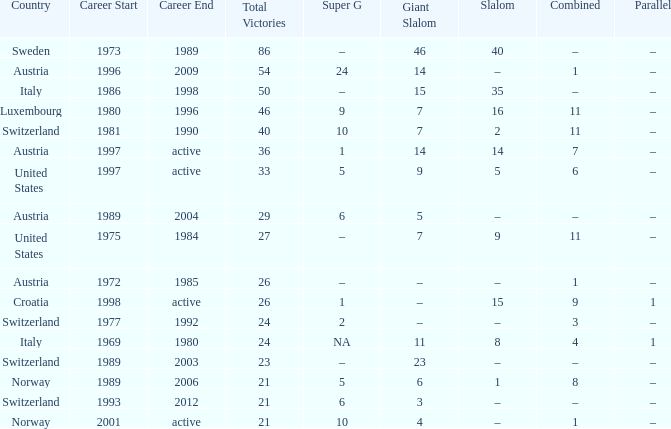What occupation has a super g of 5, and a combined of 6? 1997–active. 